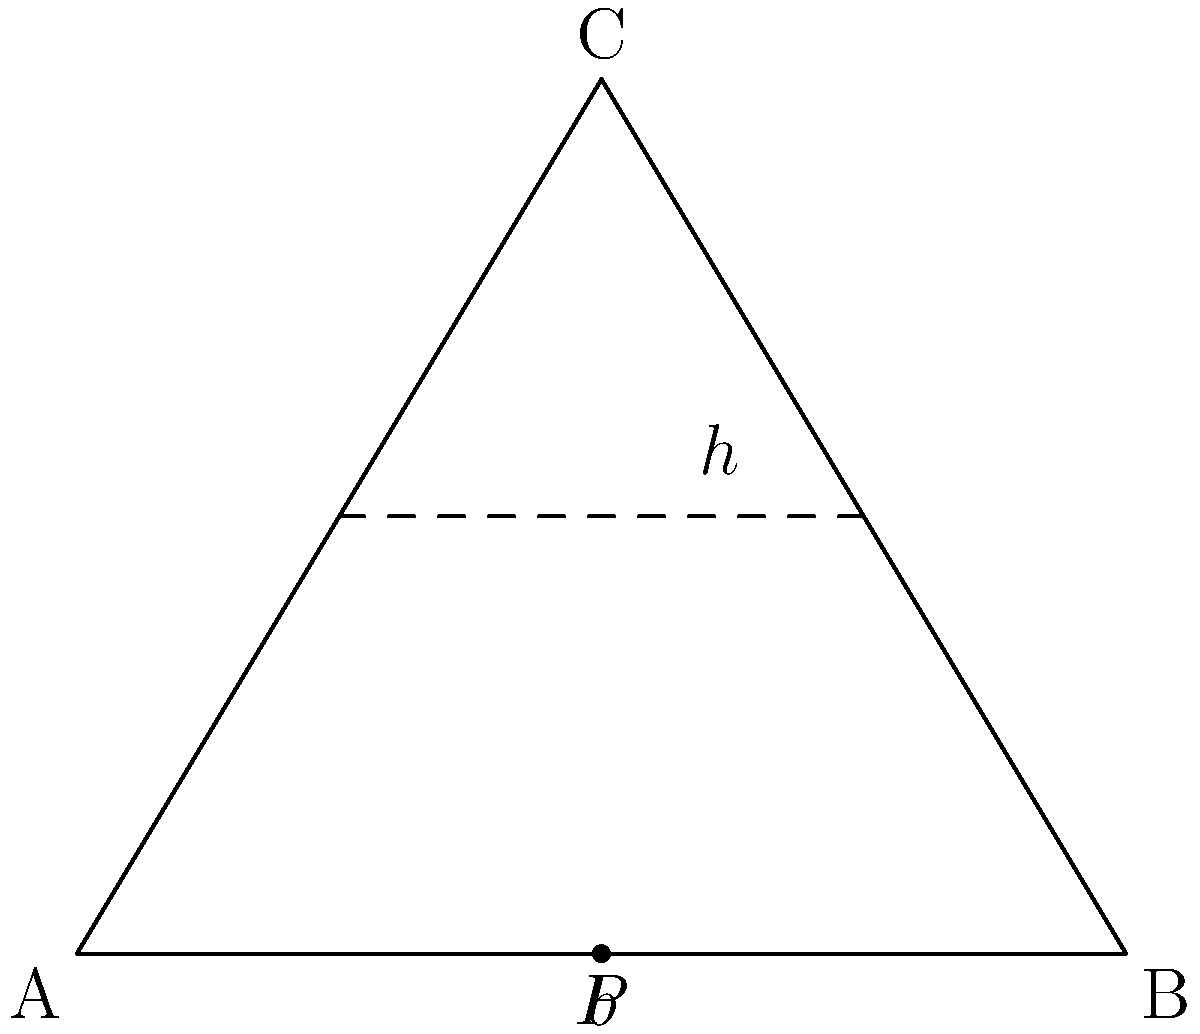In open-pit mine design, the cross-section of a pit often resembles an inverted triangle. Consider the triangle ABC in the diagram, where AB represents the pit floor and C the surface point. If the width of the pit floor (AB) is b and the height of the pit is h, what is the optimal ratio of h:b that minimizes waste rock removal while maintaining stability? To find the optimal ratio of h:b that minimizes waste rock removal while maintaining stability, we need to consider the following steps:

1. The area of the triangle represents the total volume of rock (both ore and waste) that needs to be removed.

2. The area of a triangle is given by the formula: $A = \frac{1}{2} \times base \times height$

3. In this case, $A = \frac{1}{2} \times b \times h$

4. To minimize waste rock removal, we need to minimize this area for a given pit depth (h).

5. However, we also need to consider stability. The angle of the pit walls (slope angle) is crucial for stability.

6. The tangent of the slope angle is given by: $\tan \theta = \frac{h}{\frac{1}{2}b} = \frac{2h}{b}$

7. For most rock types, a slope angle of about 45° is considered stable.

8. At 45°, $\tan 45° = 1$

9. Therefore, for optimal stability: $\frac{2h}{b} = 1$

10. Simplifying: $h = \frac{1}{2}b$

11. This gives us the optimal ratio of h:b as 1:2

Therefore, the optimal ratio of h:b that minimizes waste rock removal while maintaining stability is 1:2 or 0.5:1.
Answer: 1:2 